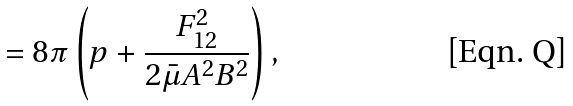Convert formula to latex. <formula><loc_0><loc_0><loc_500><loc_500>= 8 \pi \left ( p + \frac { F ^ { 2 } _ { 1 2 } } { 2 \bar { \mu } A ^ { 2 } B ^ { 2 } } \right ) ,</formula> 